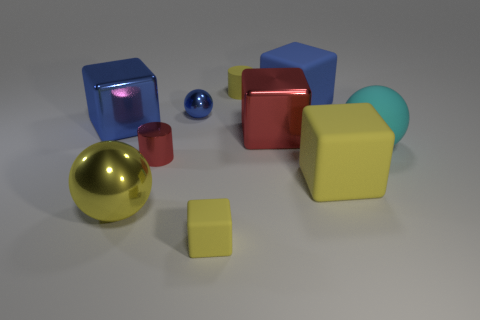There is a tiny yellow matte thing that is behind the red shiny block; what is its shape?
Keep it short and to the point. Cylinder. Is the small yellow cylinder made of the same material as the small yellow block that is in front of the tiny yellow cylinder?
Ensure brevity in your answer.  Yes. Are any tiny blue objects visible?
Provide a succinct answer. Yes. Is there a tiny blue sphere behind the yellow thing right of the big rubber cube that is to the left of the big yellow rubber object?
Offer a very short reply. Yes. What number of tiny objects are either metal cylinders or blue metal blocks?
Offer a terse response. 1. What color is the cube that is the same size as the red metal cylinder?
Give a very brief answer. Yellow. How many blue matte cubes are left of the small red cylinder?
Your answer should be very brief. 0. Are there any yellow spheres made of the same material as the small red thing?
Give a very brief answer. Yes. What is the shape of the small thing that is the same color as the small matte cylinder?
Give a very brief answer. Cube. What color is the tiny shiny thing that is left of the blue metal sphere?
Provide a succinct answer. Red. 